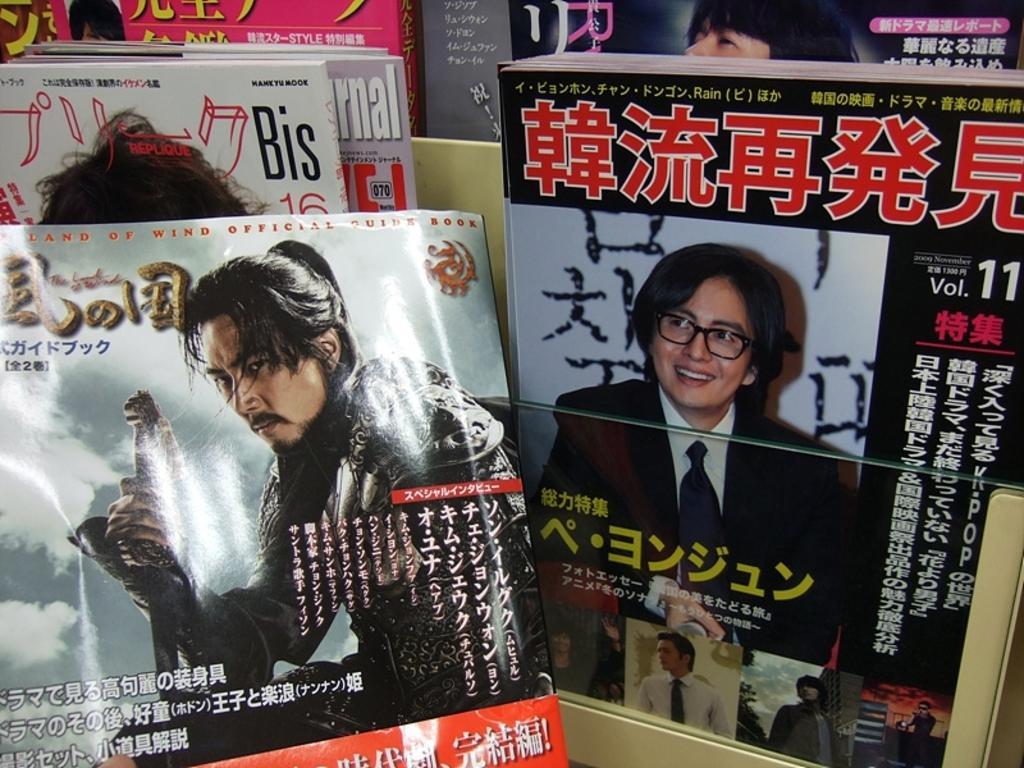Could you give a brief overview of what you see in this image? In this picture we can see objects seems to be the books and we can see the text, numbers and pictures of some persons on the covers of the books and we can see some other objects. 